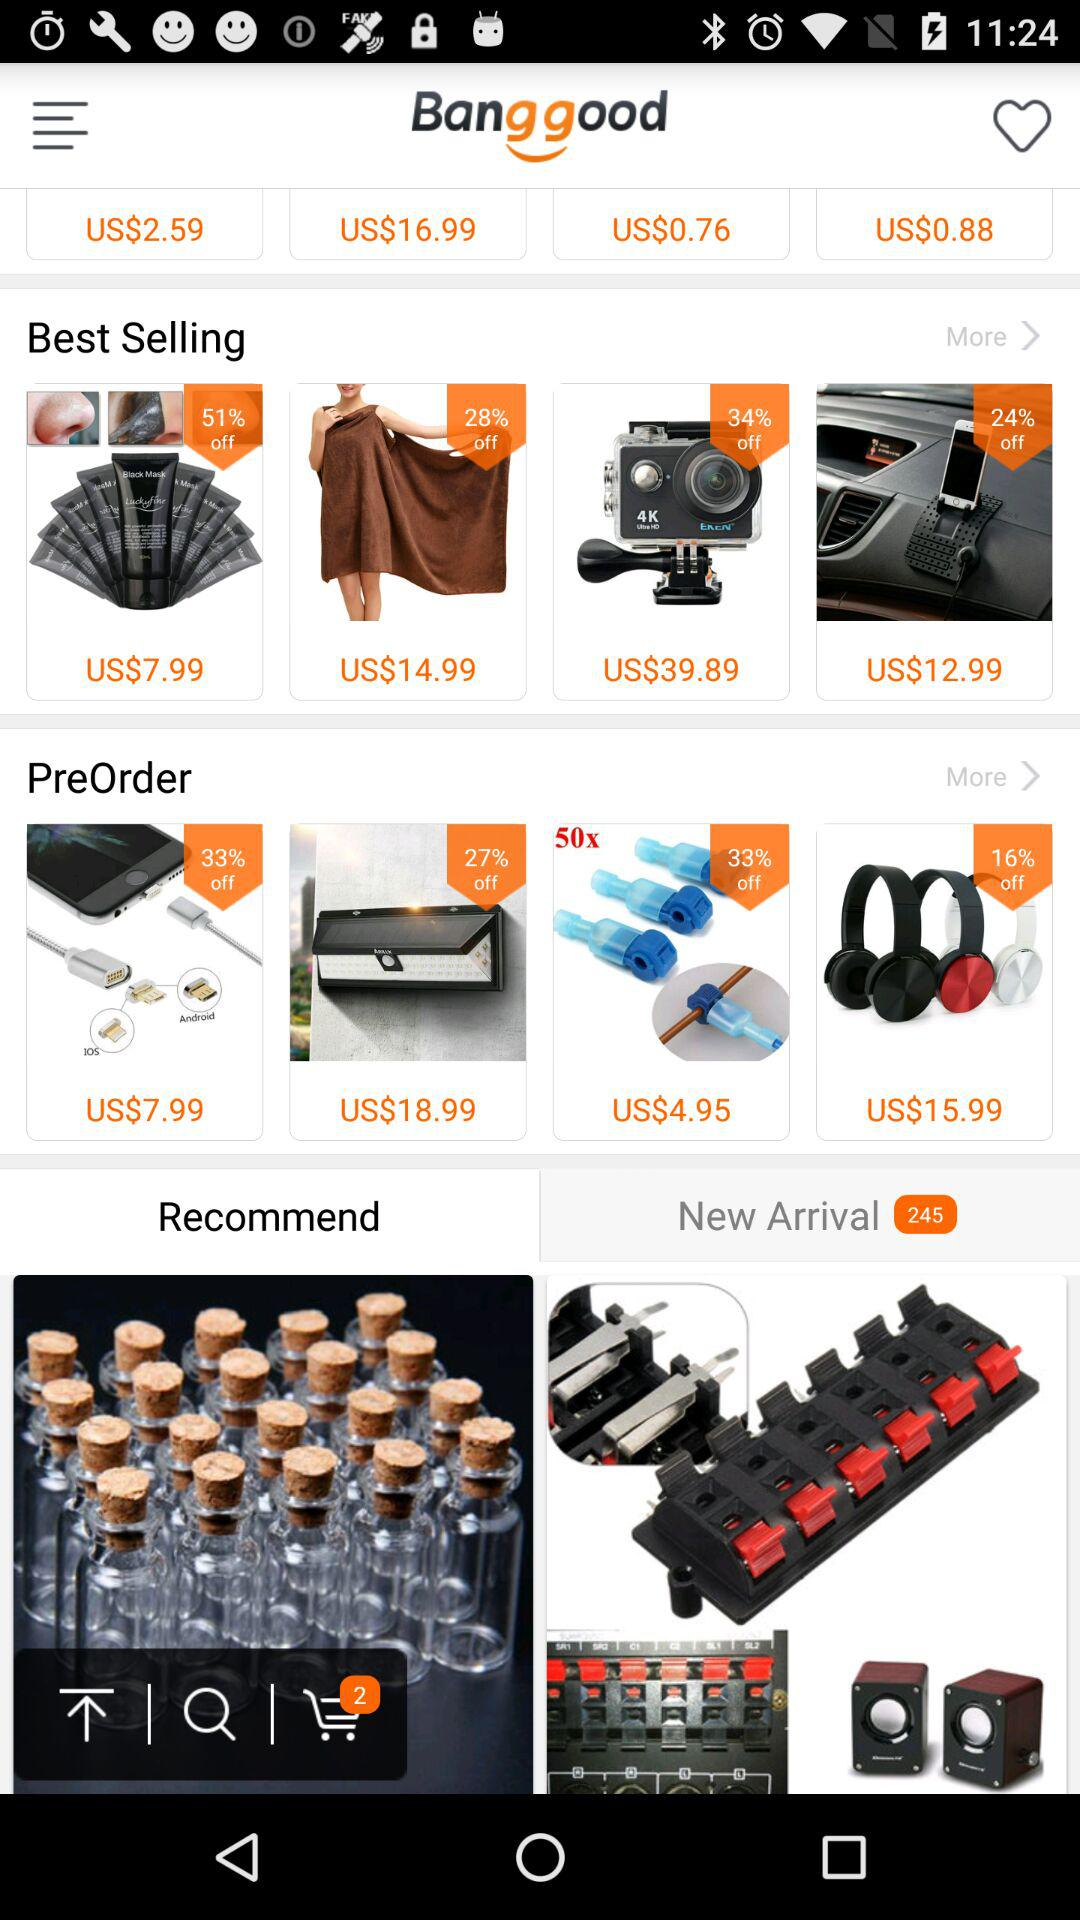How many items are in the cart? There are 2 items in the cart. 